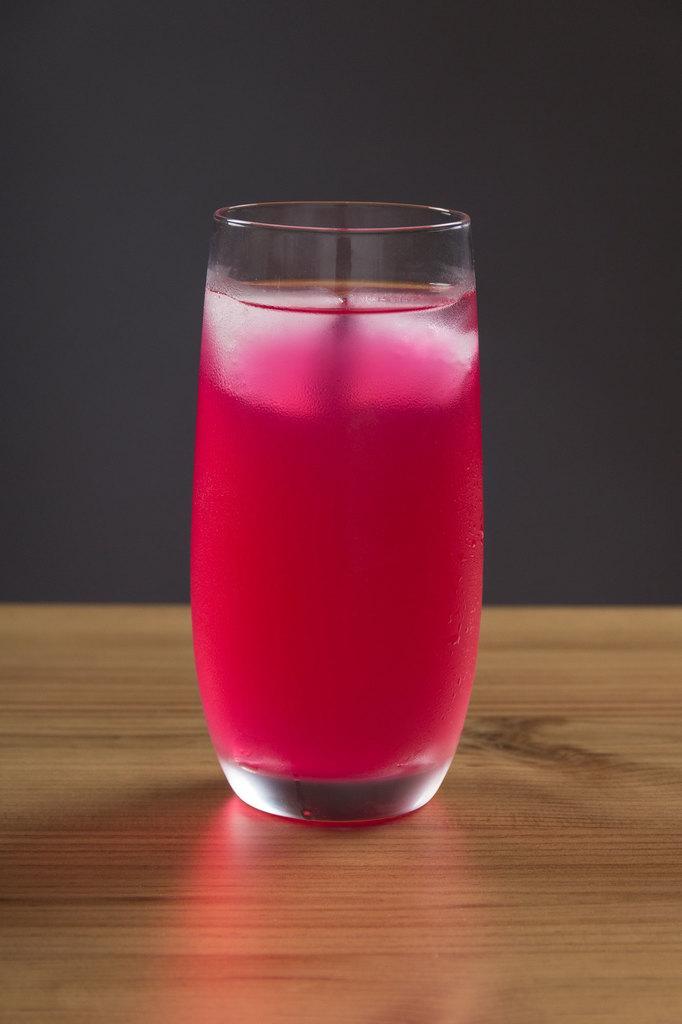In one or two sentences, can you explain what this image depicts? In the center of this picture we can see the glass of drink which is placed on the top of a wooden object which seems to be the table. In the background we can see an object which seems to be the wall. 